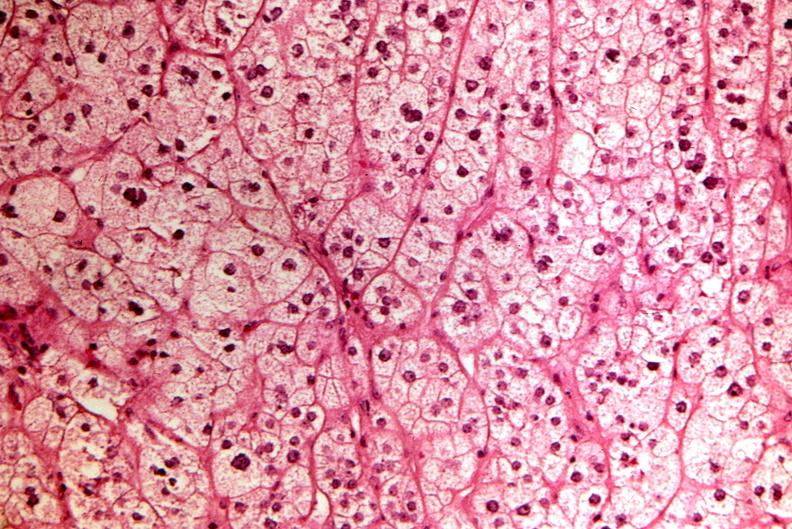what is present?
Answer the question using a single word or phrase. Endocrine 